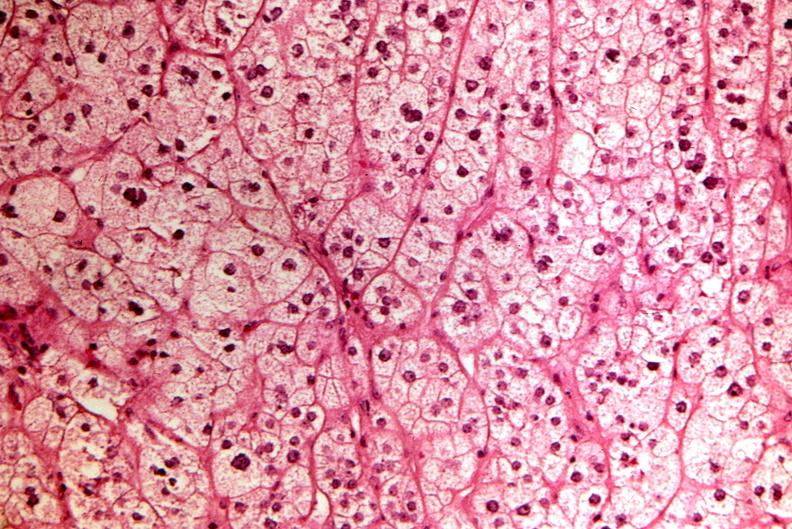what is present?
Answer the question using a single word or phrase. Endocrine 